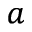Convert formula to latex. <formula><loc_0><loc_0><loc_500><loc_500>^ { a }</formula> 